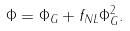<formula> <loc_0><loc_0><loc_500><loc_500>\Phi = \Phi _ { G } + f _ { N L } \Phi _ { G } ^ { 2 } .</formula> 